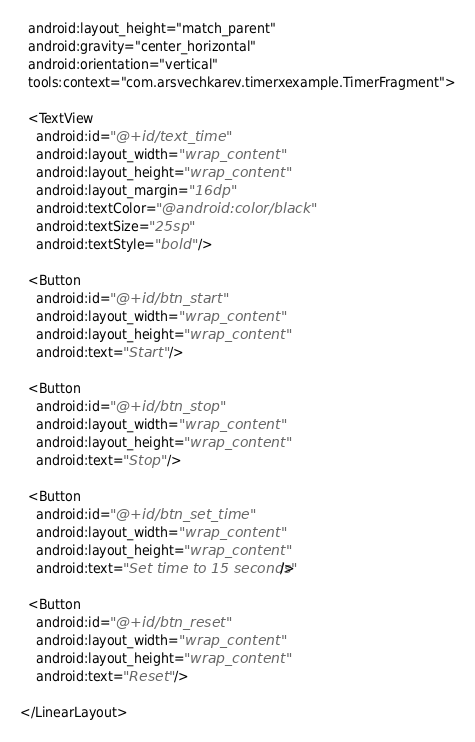<code> <loc_0><loc_0><loc_500><loc_500><_XML_>  android:layout_height="match_parent"
  android:gravity="center_horizontal"
  android:orientation="vertical"
  tools:context="com.arsvechkarev.timerxexample.TimerFragment">

  <TextView
    android:id="@+id/text_time"
    android:layout_width="wrap_content"
    android:layout_height="wrap_content"
    android:layout_margin="16dp"
    android:textColor="@android:color/black"
    android:textSize="25sp"
    android:textStyle="bold" />

  <Button
    android:id="@+id/btn_start"
    android:layout_width="wrap_content"
    android:layout_height="wrap_content"
    android:text="Start" />

  <Button
    android:id="@+id/btn_stop"
    android:layout_width="wrap_content"
    android:layout_height="wrap_content"
    android:text="Stop" />

  <Button
    android:id="@+id/btn_set_time"
    android:layout_width="wrap_content"
    android:layout_height="wrap_content"
    android:text="Set time to 15 seconds"/>

  <Button
    android:id="@+id/btn_reset"
    android:layout_width="wrap_content"
    android:layout_height="wrap_content"
    android:text="Reset" />

</LinearLayout>
</code> 